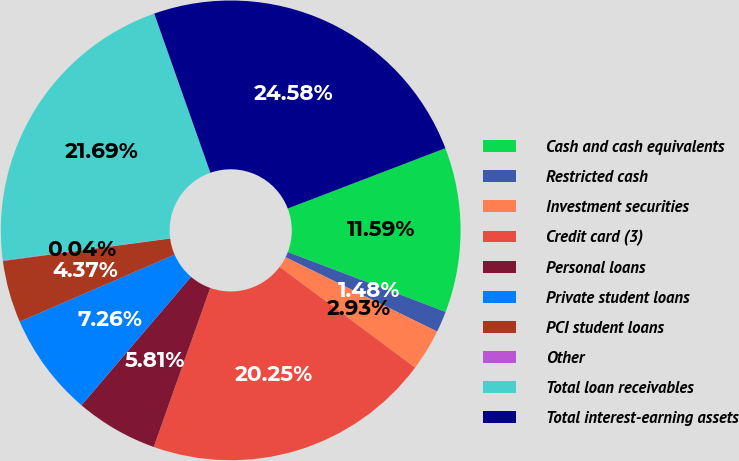<chart> <loc_0><loc_0><loc_500><loc_500><pie_chart><fcel>Cash and cash equivalents<fcel>Restricted cash<fcel>Investment securities<fcel>Credit card (3)<fcel>Personal loans<fcel>Private student loans<fcel>PCI student loans<fcel>Other<fcel>Total loan receivables<fcel>Total interest-earning assets<nl><fcel>11.59%<fcel>1.48%<fcel>2.93%<fcel>20.25%<fcel>5.81%<fcel>7.26%<fcel>4.37%<fcel>0.04%<fcel>21.69%<fcel>24.58%<nl></chart> 